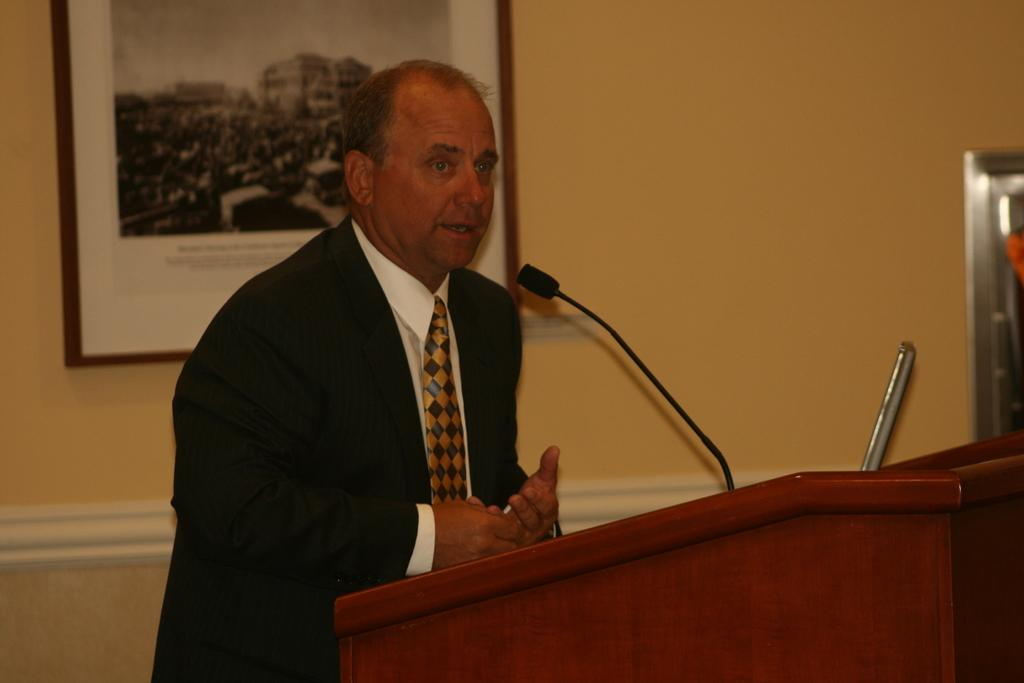Who is the main subject in the image? There is a man in the image. What is the man wearing? The man is wearing a suit and a tie. What is the man doing in the image? The man is standing near a podium and talking. What can be seen in the background of the image? There is a wall in the background of the image, and there is a frame on the wall. What type of apple can be seen in the man's hand in the image? There is no apple present in the image; the man is not holding anything in his hand. Can you tell me how many pencils are visible on the podium in the image? There are no pencils visible on the podium in the image. 